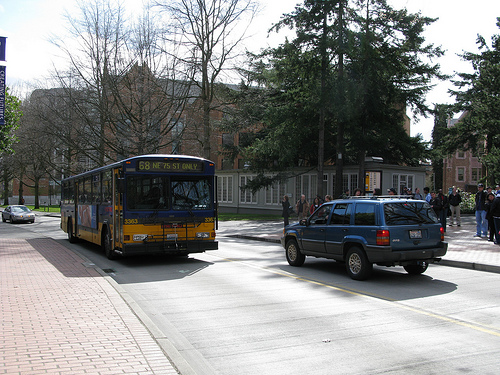Are there any people in this image? Yes, multiple individuals are visible walking on the sidewalks, which adds a sense of daily life and activity to the scene. Can you tell me what they are doing? The people in the image are engaged in typical pedestrian activities such as walking, possibly heading towards a destination like a nearby building or public transit stop. 